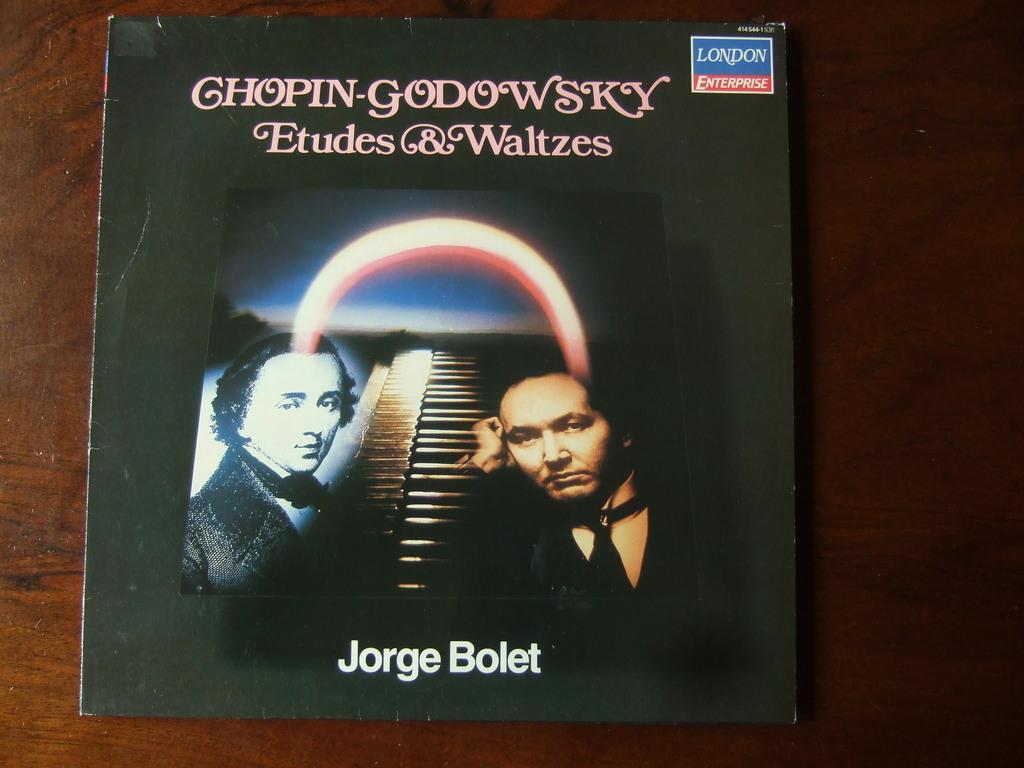Please provide a concise description of this image. In this picture we can see a album cover. 